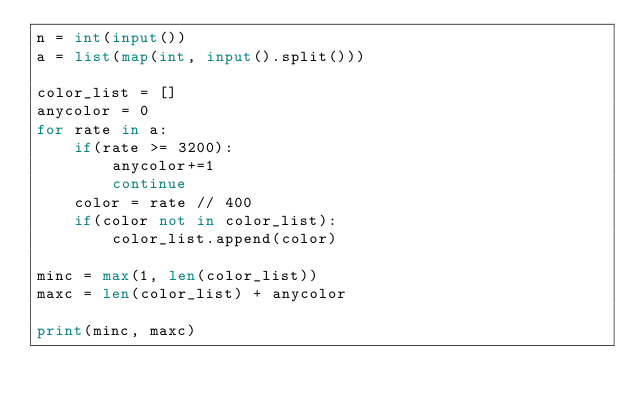Convert code to text. <code><loc_0><loc_0><loc_500><loc_500><_Python_>n = int(input())
a = list(map(int, input().split()))

color_list = []
anycolor = 0
for rate in a:
    if(rate >= 3200):
        anycolor+=1
        continue
    color = rate // 400
    if(color not in color_list):
        color_list.append(color)

minc = max(1, len(color_list))
maxc = len(color_list) + anycolor

print(minc, maxc)
</code> 